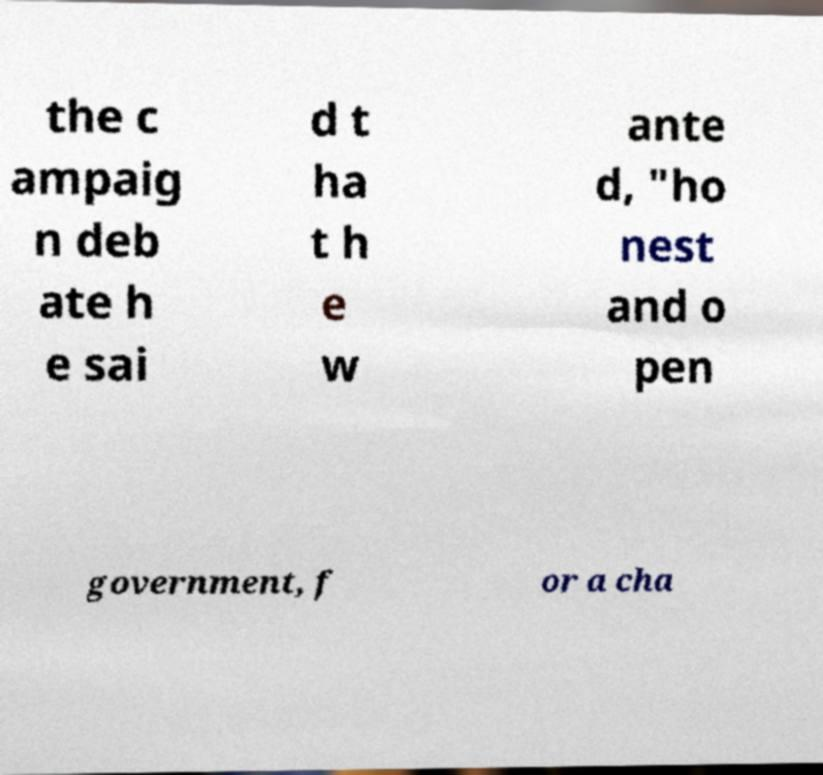Could you assist in decoding the text presented in this image and type it out clearly? the c ampaig n deb ate h e sai d t ha t h e w ante d, "ho nest and o pen government, f or a cha 